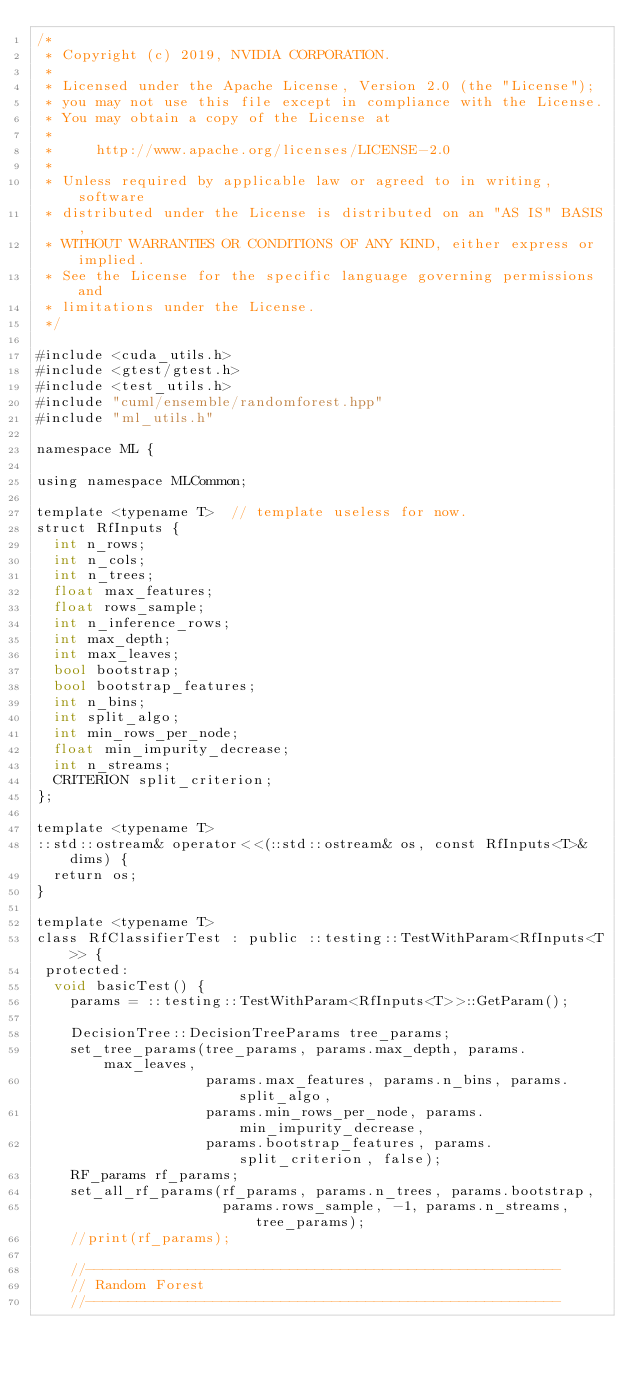<code> <loc_0><loc_0><loc_500><loc_500><_Cuda_>/*
 * Copyright (c) 2019, NVIDIA CORPORATION.
 *
 * Licensed under the Apache License, Version 2.0 (the "License");
 * you may not use this file except in compliance with the License.
 * You may obtain a copy of the License at
 *
 *     http://www.apache.org/licenses/LICENSE-2.0
 *
 * Unless required by applicable law or agreed to in writing, software
 * distributed under the License is distributed on an "AS IS" BASIS,
 * WITHOUT WARRANTIES OR CONDITIONS OF ANY KIND, either express or implied.
 * See the License for the specific language governing permissions and
 * limitations under the License.
 */

#include <cuda_utils.h>
#include <gtest/gtest.h>
#include <test_utils.h>
#include "cuml/ensemble/randomforest.hpp"
#include "ml_utils.h"

namespace ML {

using namespace MLCommon;

template <typename T>  // template useless for now.
struct RfInputs {
  int n_rows;
  int n_cols;
  int n_trees;
  float max_features;
  float rows_sample;
  int n_inference_rows;
  int max_depth;
  int max_leaves;
  bool bootstrap;
  bool bootstrap_features;
  int n_bins;
  int split_algo;
  int min_rows_per_node;
  float min_impurity_decrease;
  int n_streams;
  CRITERION split_criterion;
};

template <typename T>
::std::ostream& operator<<(::std::ostream& os, const RfInputs<T>& dims) {
  return os;
}

template <typename T>
class RfClassifierTest : public ::testing::TestWithParam<RfInputs<T>> {
 protected:
  void basicTest() {
    params = ::testing::TestWithParam<RfInputs<T>>::GetParam();

    DecisionTree::DecisionTreeParams tree_params;
    set_tree_params(tree_params, params.max_depth, params.max_leaves,
                    params.max_features, params.n_bins, params.split_algo,
                    params.min_rows_per_node, params.min_impurity_decrease,
                    params.bootstrap_features, params.split_criterion, false);
    RF_params rf_params;
    set_all_rf_params(rf_params, params.n_trees, params.bootstrap,
                      params.rows_sample, -1, params.n_streams, tree_params);
    //print(rf_params);

    //--------------------------------------------------------
    // Random Forest
    //--------------------------------------------------------
</code> 